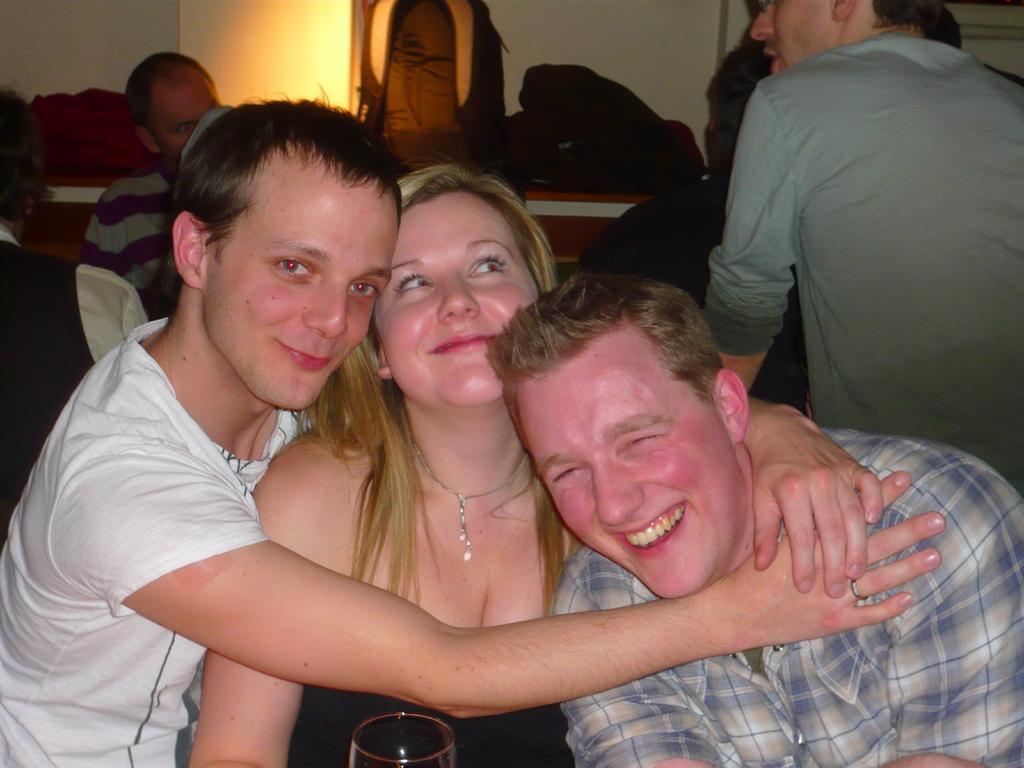Please provide a concise description of this image. This is an inside view. Here I can see three persons smiling. At the bottom there is a glass. In the background, I can see some more people and there is a table on which few bags are placed. At the top of the image there is a wall. 